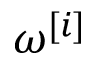<formula> <loc_0><loc_0><loc_500><loc_500>\omega ^ { [ i ] }</formula> 